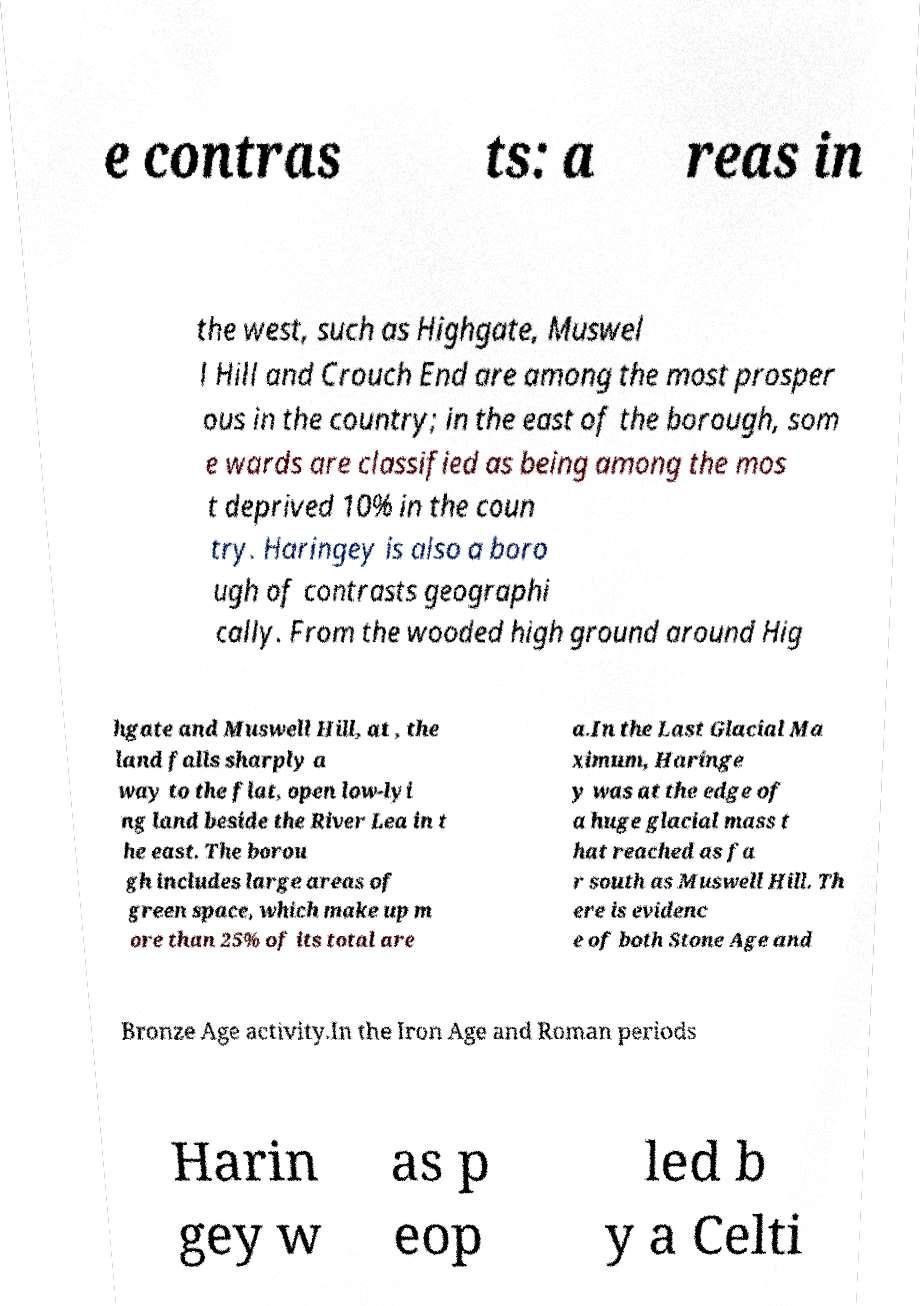I need the written content from this picture converted into text. Can you do that? e contras ts: a reas in the west, such as Highgate, Muswel l Hill and Crouch End are among the most prosper ous in the country; in the east of the borough, som e wards are classified as being among the mos t deprived 10% in the coun try. Haringey is also a boro ugh of contrasts geographi cally. From the wooded high ground around Hig hgate and Muswell Hill, at , the land falls sharply a way to the flat, open low-lyi ng land beside the River Lea in t he east. The borou gh includes large areas of green space, which make up m ore than 25% of its total are a.In the Last Glacial Ma ximum, Haringe y was at the edge of a huge glacial mass t hat reached as fa r south as Muswell Hill. Th ere is evidenc e of both Stone Age and Bronze Age activity.In the Iron Age and Roman periods Harin gey w as p eop led b y a Celti 